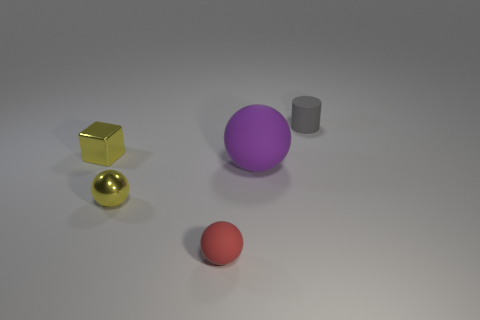Subtract all yellow balls. How many balls are left? 2 Add 3 tiny purple things. How many objects exist? 8 Subtract 1 balls. How many balls are left? 2 Subtract 0 blue cylinders. How many objects are left? 5 Subtract all cylinders. How many objects are left? 4 Subtract all green balls. Subtract all purple blocks. How many balls are left? 3 Subtract all spheres. Subtract all large cyan metal objects. How many objects are left? 2 Add 2 matte spheres. How many matte spheres are left? 4 Add 5 tiny red matte objects. How many tiny red matte objects exist? 6 